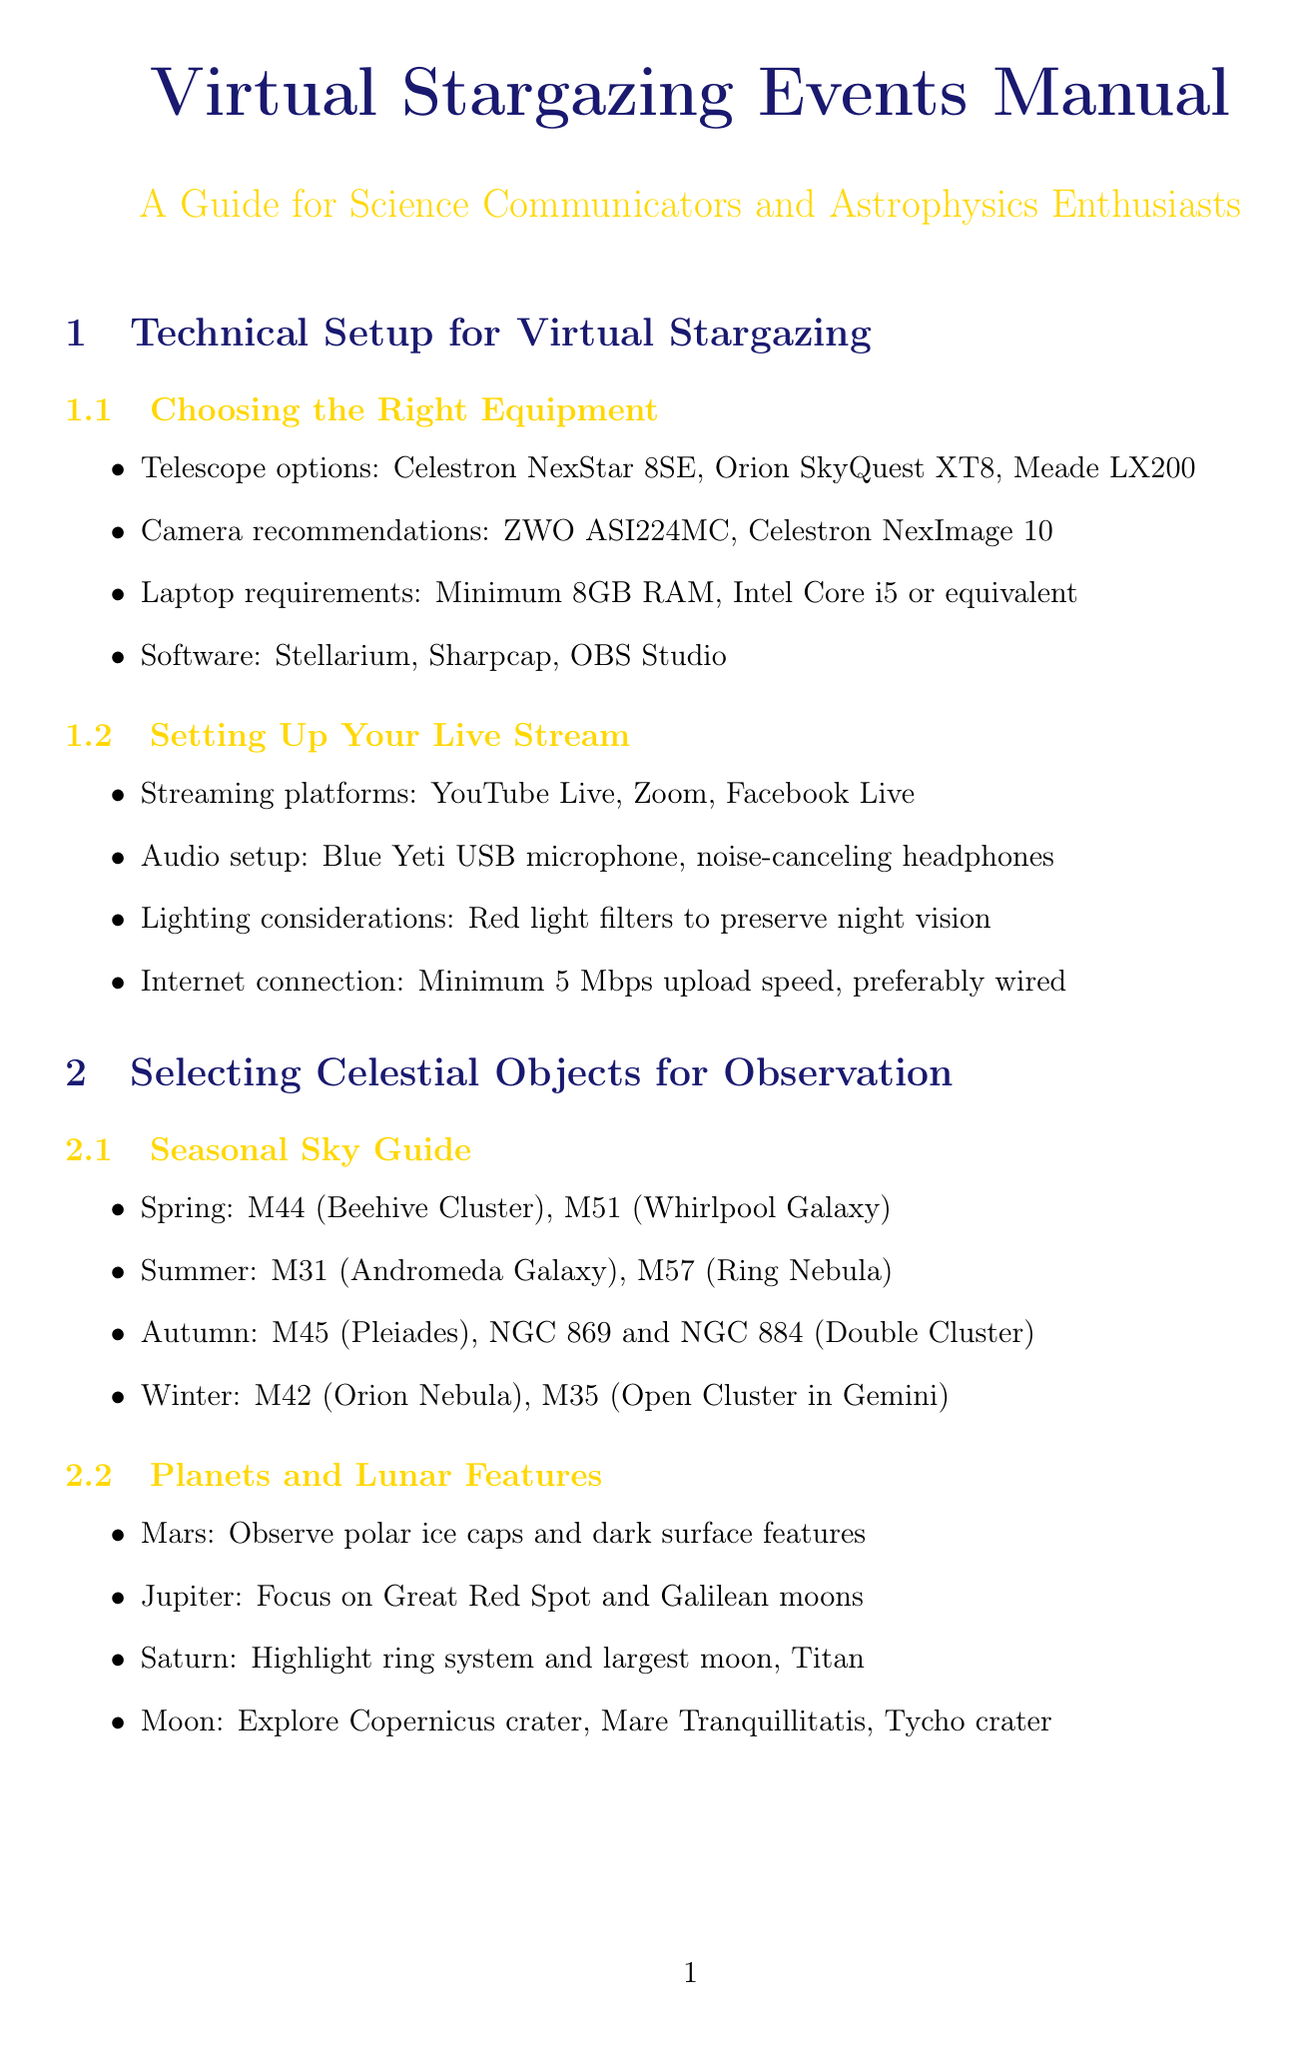What are the recommended telescopes? The document lists telescope options for virtual stargazing events.
Answer: Celestron NexStar 8SE, Orion SkyQuest XT8, Meade LX200 What is the minimum laptop requirement? The document specifies the minimum specifications needed for a laptop to conduct virtual stargazing.
Answer: Minimum 8GB RAM, Intel Core i5 or equivalent Which streaming platform is mentioned? The document suggests different platforms for live streaming the stargazing event.
Answer: YouTube Live What celestial object can you observe in winter? The document provides a seasonal sky guide for celestial observations.
Answer: M42 (Orion Nebula) What type of quiz is suggested for audience engagement? The manual advises on creating content for interactive sessions with the audience.
Answer: Cosmic Trivia Who should filter and organize questions during Q&A? The document mentions roles for managing audience interaction during virtual events.
Answer: Moderator Which book is recommended in the astrophysics insights section? The document recommends literature for a deeper understanding of astrophysics.
Answer: A Brief History of Time by Stephen Hawking What is a suggested monthly themed event? The document includes ideas for fostering community engagement in stargazing.
Answer: Nebulae Night 